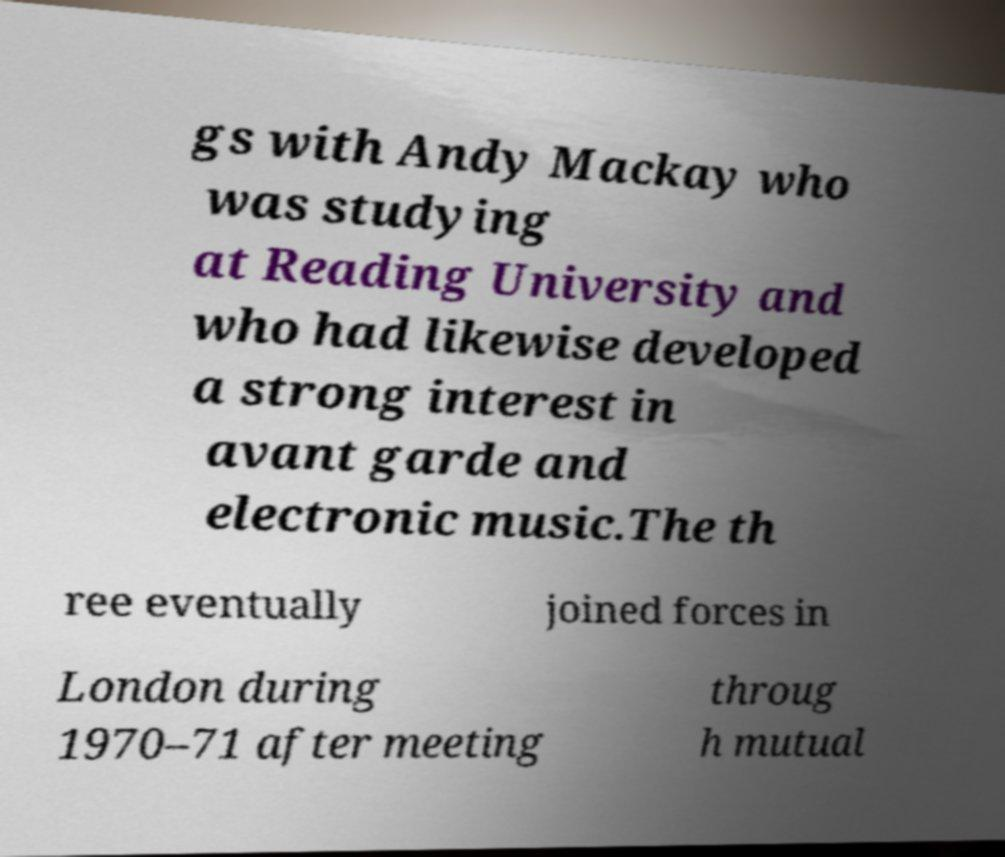I need the written content from this picture converted into text. Can you do that? gs with Andy Mackay who was studying at Reading University and who had likewise developed a strong interest in avant garde and electronic music.The th ree eventually joined forces in London during 1970–71 after meeting throug h mutual 